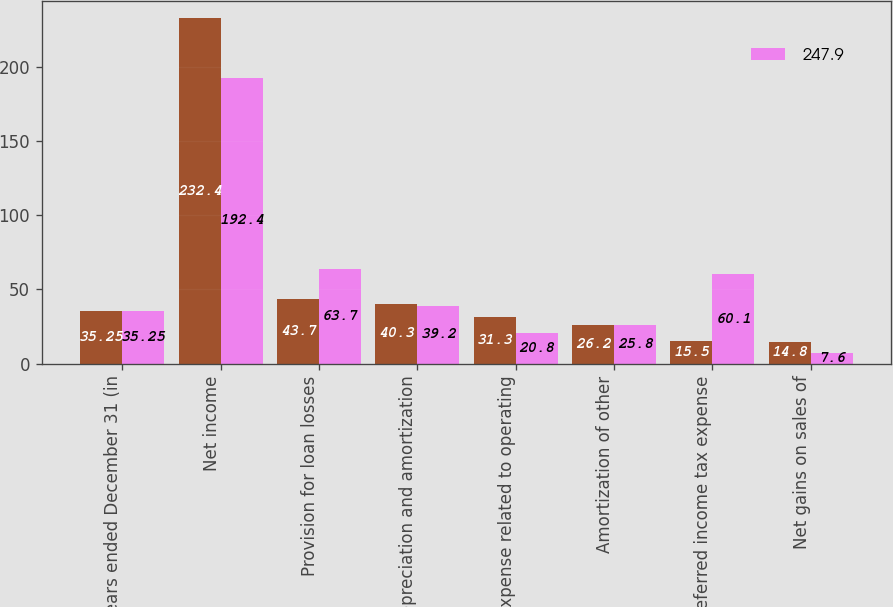Convert chart to OTSL. <chart><loc_0><loc_0><loc_500><loc_500><stacked_bar_chart><ecel><fcel>Years ended December 31 (in<fcel>Net income<fcel>Provision for loan losses<fcel>Depreciation and amortization<fcel>Expense related to operating<fcel>Amortization of other<fcel>Deferred income tax expense<fcel>Net gains on sales of<nl><fcel>nan<fcel>35.25<fcel>232.4<fcel>43.7<fcel>40.3<fcel>31.3<fcel>26.2<fcel>15.5<fcel>14.8<nl><fcel>247.9<fcel>35.25<fcel>192.4<fcel>63.7<fcel>39.2<fcel>20.8<fcel>25.8<fcel>60.1<fcel>7.6<nl></chart> 